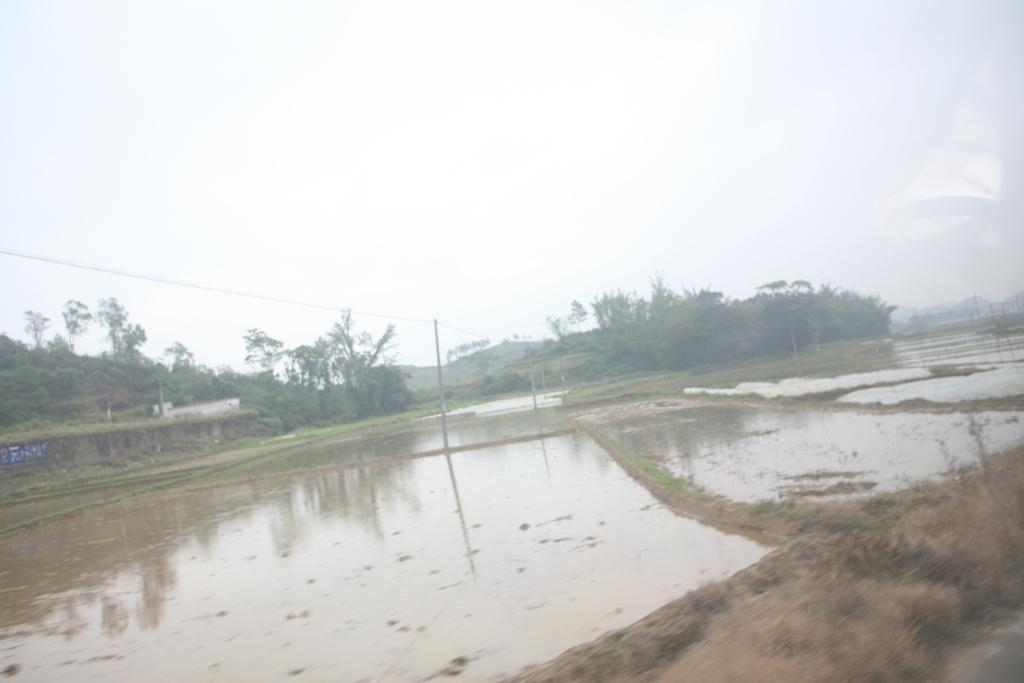What is covering the mud in the image? There is water on the mud in the image. What structures can be seen in the image? There are poles and a house in the image. What type of vegetation is present in the image? There are trees and grass in the image. What geographical feature is visible in the background of the image? There are mountains in the image. What type of carriage is being pulled by horses in the image? There is no carriage or horses present in the image. What activity is taking place in the image? The image does not depict any specific activity; it shows water on mud, poles, trees, a house, mountains, and grass. 